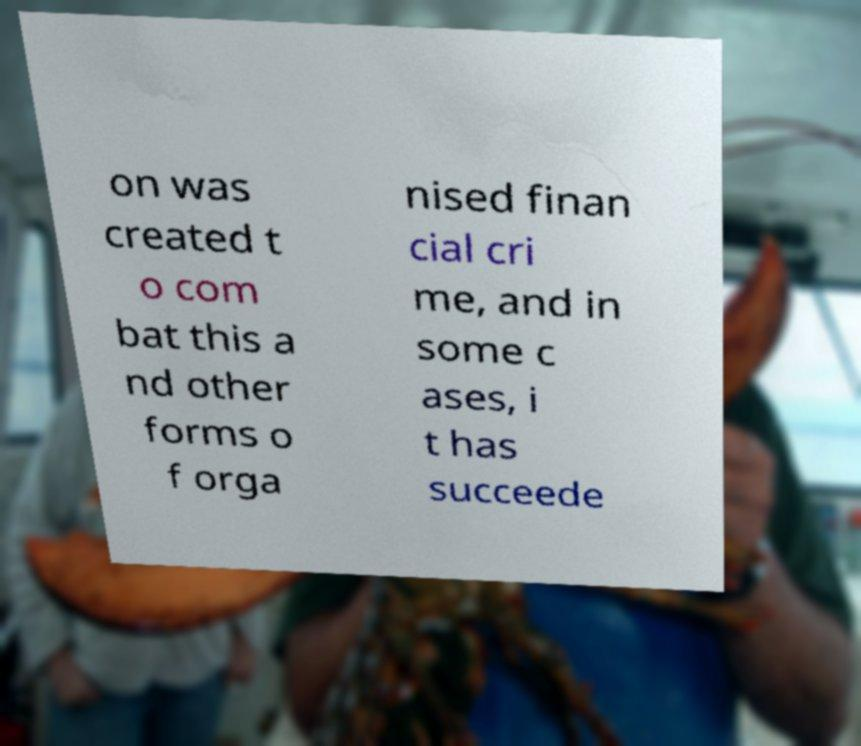Can you accurately transcribe the text from the provided image for me? on was created t o com bat this a nd other forms o f orga nised finan cial cri me, and in some c ases, i t has succeede 